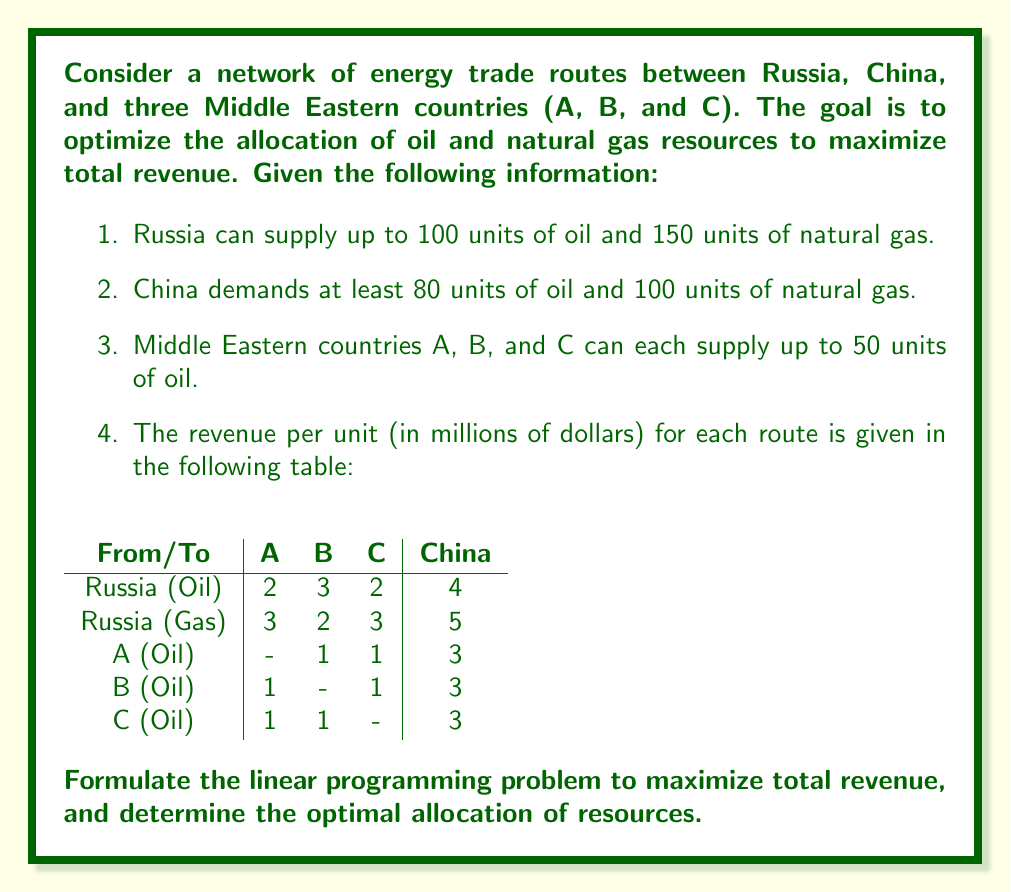Can you solve this math problem? To formulate this linear programming problem, we need to define our decision variables, objective function, and constraints.

Decision Variables:
Let $x_{ij}$ represent the amount of oil or gas sent from country i to country j.
- $x_{RO,i}$: Oil from Russia to country i (A, B, C, or China)
- $x_{RG,i}$: Natural gas from Russia to country i (A, B, C, or China)
- $x_{A,i}$: Oil from country A to country i (B, C, or China)
- $x_{B,i}$: Oil from country B to country i (A, C, or China)
- $x_{C,i}$: Oil from country C to country i (A, B, or China)

Objective Function:
Maximize total revenue:

$$\begin{align*}
Z = 2x_{RO,A} &+ 3x_{RO,B} + 2x_{RO,C} + 4x_{RO,China} \\
&+ 3x_{RG,A} + 2x_{RG,B} + 3x_{RG,C} + 5x_{RG,China} \\
&+ x_{A,B} + x_{A,C} + 3x_{A,China} \\
&+ x_{B,A} + x_{B,C} + 3x_{B,China} \\
&+ x_{C,A} + x_{C,B} + 3x_{C,China}
\end{align*}$$

Constraints:
1. Supply constraints:
   - Russia Oil: $x_{RO,A} + x_{RO,B} + x_{RO,C} + x_{RO,China} \leq 100$
   - Russia Gas: $x_{RG,A} + x_{RG,B} + x_{RG,C} + x_{RG,China} \leq 150$
   - Country A Oil: $x_{A,B} + x_{A,C} + x_{A,China} \leq 50$
   - Country B Oil: $x_{B,A} + x_{B,C} + x_{B,China} \leq 50$
   - Country C Oil: $x_{C,A} + x_{C,B} + x_{C,China} \leq 50$

2. Demand constraints for China:
   - Oil: $x_{RO,China} + x_{A,China} + x_{B,China} + x_{C,China} \geq 80$
   - Gas: $x_{RG,China} \geq 100$

3. Non-negativity constraints:
   All $x_{ij} \geq 0$

To solve this linear programming problem, we would use a solver like the simplex method or interior point method. The solution would provide the optimal allocation of resources to maximize total revenue.
Answer: The formulation of the linear programming problem is the answer to this question. The optimal solution would depend on using a linear programming solver to find the specific values for each decision variable that maximize the objective function while satisfying all constraints. 